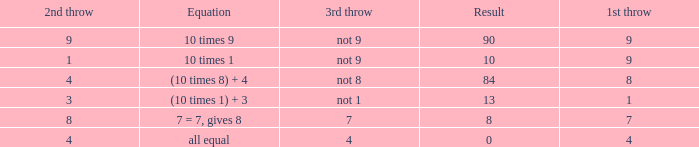If the equation is (10 times 8) + 4, what would be the 2nd throw? 4.0. 